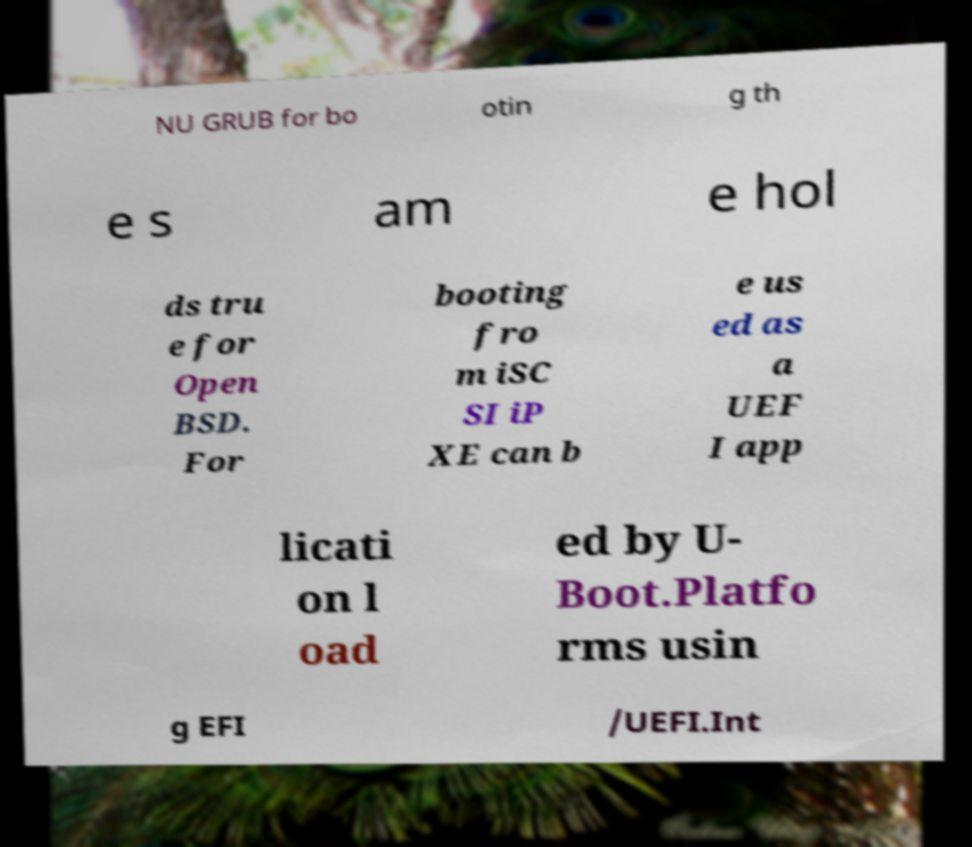Please identify and transcribe the text found in this image. NU GRUB for bo otin g th e s am e hol ds tru e for Open BSD. For booting fro m iSC SI iP XE can b e us ed as a UEF I app licati on l oad ed by U- Boot.Platfo rms usin g EFI /UEFI.Int 